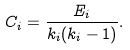Convert formula to latex. <formula><loc_0><loc_0><loc_500><loc_500>C _ { i } = \frac { E _ { i } } { k _ { i } ( k _ { i } - 1 ) } .</formula> 